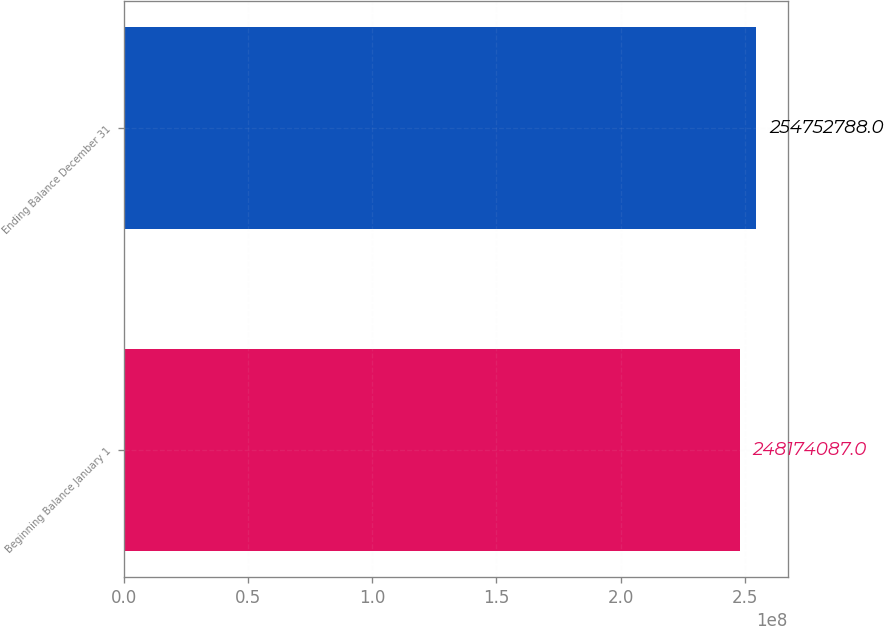<chart> <loc_0><loc_0><loc_500><loc_500><bar_chart><fcel>Beginning Balance January 1<fcel>Ending Balance December 31<nl><fcel>2.48174e+08<fcel>2.54753e+08<nl></chart> 